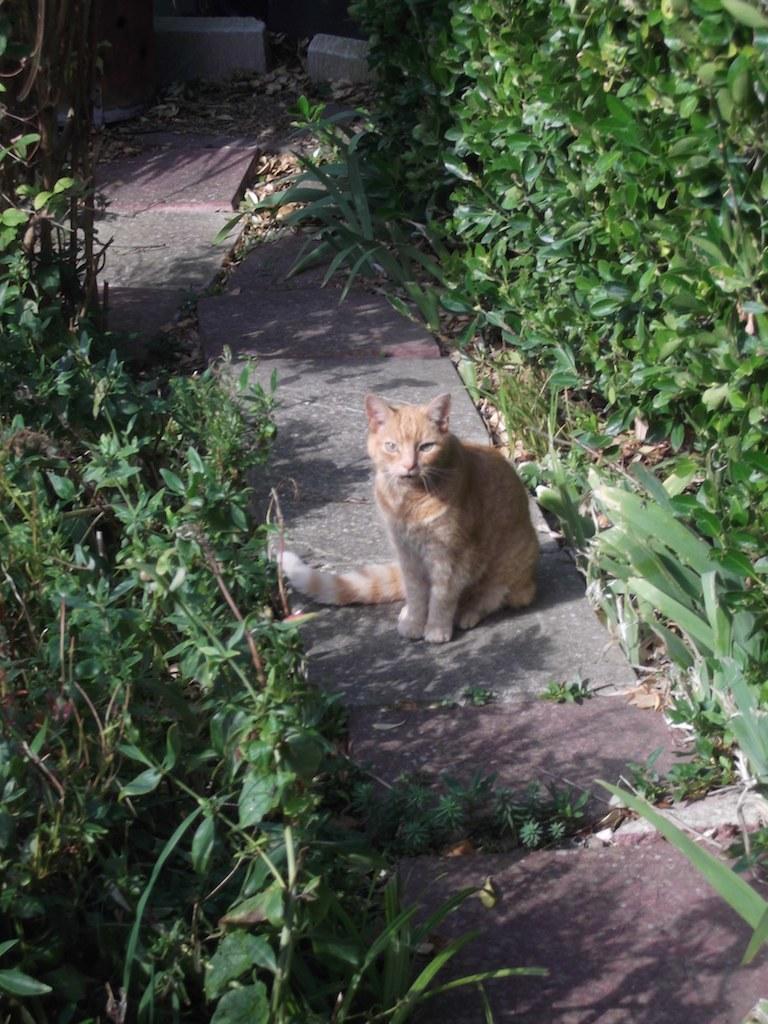Can you describe this image briefly? In the center of the image there is a cat. At the bottom we can see laystones. In the background there are bushes and plants. 